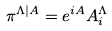<formula> <loc_0><loc_0><loc_500><loc_500>\pi ^ { \Lambda | A } = e ^ { i A } A _ { i } ^ { \Lambda }</formula> 